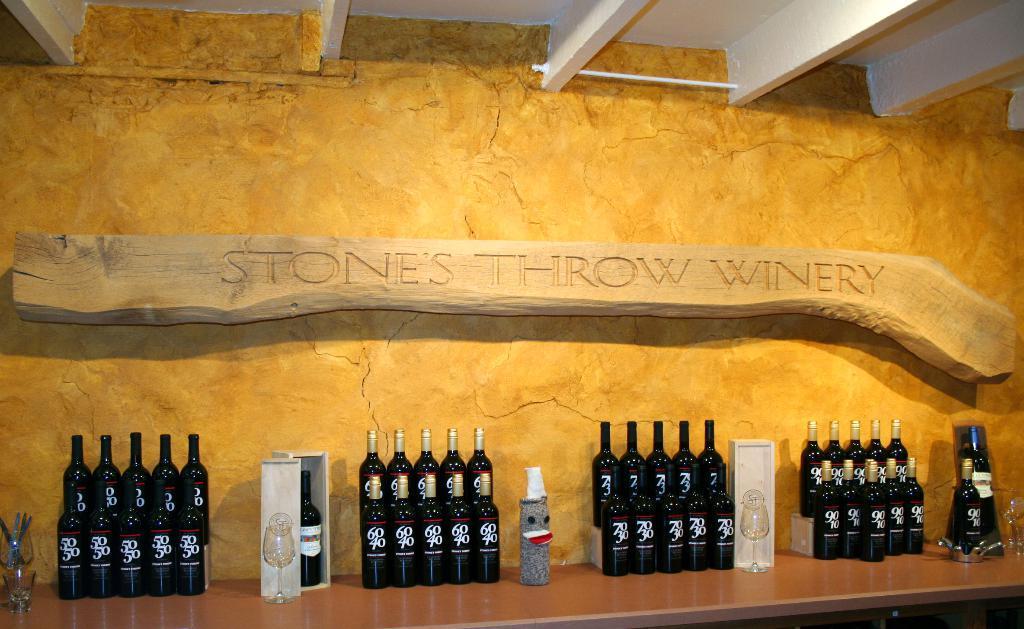In one or two sentences, can you explain what this image depicts? In this picture I can see the brown color surface on which there are number of bottles, few glasses and 2 white color boxes. In the background I see the wall on which there is a wooden thing on which there is something written. On the top of this image I see the ceiling. 